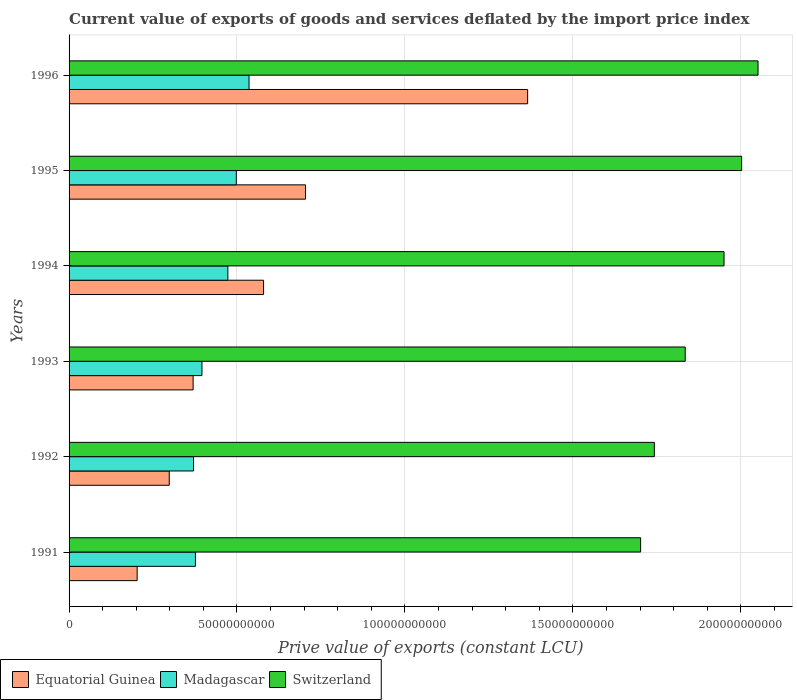Are the number of bars per tick equal to the number of legend labels?
Ensure brevity in your answer.  Yes. How many bars are there on the 4th tick from the top?
Ensure brevity in your answer.  3. In how many cases, is the number of bars for a given year not equal to the number of legend labels?
Offer a very short reply. 0. What is the prive value of exports in Switzerland in 1992?
Provide a succinct answer. 1.74e+11. Across all years, what is the maximum prive value of exports in Equatorial Guinea?
Provide a succinct answer. 1.37e+11. Across all years, what is the minimum prive value of exports in Switzerland?
Ensure brevity in your answer.  1.70e+11. In which year was the prive value of exports in Madagascar minimum?
Make the answer very short. 1992. What is the total prive value of exports in Madagascar in the graph?
Offer a very short reply. 2.65e+11. What is the difference between the prive value of exports in Switzerland in 1993 and that in 1995?
Ensure brevity in your answer.  -1.68e+1. What is the difference between the prive value of exports in Switzerland in 1993 and the prive value of exports in Madagascar in 1991?
Provide a short and direct response. 1.46e+11. What is the average prive value of exports in Equatorial Guinea per year?
Offer a terse response. 5.86e+1. In the year 1994, what is the difference between the prive value of exports in Equatorial Guinea and prive value of exports in Madagascar?
Provide a short and direct response. 1.06e+1. What is the ratio of the prive value of exports in Switzerland in 1993 to that in 1994?
Ensure brevity in your answer.  0.94. Is the prive value of exports in Madagascar in 1992 less than that in 1996?
Keep it short and to the point. Yes. Is the difference between the prive value of exports in Equatorial Guinea in 1993 and 1995 greater than the difference between the prive value of exports in Madagascar in 1993 and 1995?
Your answer should be very brief. No. What is the difference between the highest and the second highest prive value of exports in Switzerland?
Give a very brief answer. 4.89e+09. What is the difference between the highest and the lowest prive value of exports in Equatorial Guinea?
Provide a succinct answer. 1.16e+11. Is the sum of the prive value of exports in Madagascar in 1992 and 1994 greater than the maximum prive value of exports in Equatorial Guinea across all years?
Provide a short and direct response. No. What does the 3rd bar from the top in 1996 represents?
Provide a succinct answer. Equatorial Guinea. What does the 1st bar from the bottom in 1992 represents?
Your answer should be compact. Equatorial Guinea. How many bars are there?
Keep it short and to the point. 18. How many years are there in the graph?
Give a very brief answer. 6. What is the difference between two consecutive major ticks on the X-axis?
Your answer should be compact. 5.00e+1. Does the graph contain any zero values?
Keep it short and to the point. No. Does the graph contain grids?
Your answer should be very brief. Yes. Where does the legend appear in the graph?
Your answer should be compact. Bottom left. How many legend labels are there?
Ensure brevity in your answer.  3. What is the title of the graph?
Provide a short and direct response. Current value of exports of goods and services deflated by the import price index. What is the label or title of the X-axis?
Offer a very short reply. Prive value of exports (constant LCU). What is the Prive value of exports (constant LCU) of Equatorial Guinea in 1991?
Offer a terse response. 2.03e+1. What is the Prive value of exports (constant LCU) in Madagascar in 1991?
Make the answer very short. 3.76e+1. What is the Prive value of exports (constant LCU) in Switzerland in 1991?
Make the answer very short. 1.70e+11. What is the Prive value of exports (constant LCU) of Equatorial Guinea in 1992?
Give a very brief answer. 2.98e+1. What is the Prive value of exports (constant LCU) of Madagascar in 1992?
Your answer should be very brief. 3.71e+1. What is the Prive value of exports (constant LCU) in Switzerland in 1992?
Your response must be concise. 1.74e+11. What is the Prive value of exports (constant LCU) of Equatorial Guinea in 1993?
Offer a terse response. 3.69e+1. What is the Prive value of exports (constant LCU) in Madagascar in 1993?
Ensure brevity in your answer.  3.96e+1. What is the Prive value of exports (constant LCU) of Switzerland in 1993?
Provide a short and direct response. 1.83e+11. What is the Prive value of exports (constant LCU) of Equatorial Guinea in 1994?
Keep it short and to the point. 5.79e+1. What is the Prive value of exports (constant LCU) in Madagascar in 1994?
Ensure brevity in your answer.  4.73e+1. What is the Prive value of exports (constant LCU) of Switzerland in 1994?
Your answer should be very brief. 1.95e+11. What is the Prive value of exports (constant LCU) of Equatorial Guinea in 1995?
Keep it short and to the point. 7.04e+1. What is the Prive value of exports (constant LCU) of Madagascar in 1995?
Give a very brief answer. 4.98e+1. What is the Prive value of exports (constant LCU) in Switzerland in 1995?
Provide a short and direct response. 2.00e+11. What is the Prive value of exports (constant LCU) in Equatorial Guinea in 1996?
Provide a short and direct response. 1.37e+11. What is the Prive value of exports (constant LCU) of Madagascar in 1996?
Provide a short and direct response. 5.36e+1. What is the Prive value of exports (constant LCU) in Switzerland in 1996?
Ensure brevity in your answer.  2.05e+11. Across all years, what is the maximum Prive value of exports (constant LCU) in Equatorial Guinea?
Your answer should be very brief. 1.37e+11. Across all years, what is the maximum Prive value of exports (constant LCU) in Madagascar?
Provide a succinct answer. 5.36e+1. Across all years, what is the maximum Prive value of exports (constant LCU) in Switzerland?
Your answer should be compact. 2.05e+11. Across all years, what is the minimum Prive value of exports (constant LCU) in Equatorial Guinea?
Your answer should be compact. 2.03e+1. Across all years, what is the minimum Prive value of exports (constant LCU) in Madagascar?
Your answer should be very brief. 3.71e+1. Across all years, what is the minimum Prive value of exports (constant LCU) in Switzerland?
Offer a very short reply. 1.70e+11. What is the total Prive value of exports (constant LCU) in Equatorial Guinea in the graph?
Provide a short and direct response. 3.52e+11. What is the total Prive value of exports (constant LCU) of Madagascar in the graph?
Your answer should be compact. 2.65e+11. What is the total Prive value of exports (constant LCU) of Switzerland in the graph?
Keep it short and to the point. 1.13e+12. What is the difference between the Prive value of exports (constant LCU) in Equatorial Guinea in 1991 and that in 1992?
Your answer should be very brief. -9.55e+09. What is the difference between the Prive value of exports (constant LCU) of Madagascar in 1991 and that in 1992?
Ensure brevity in your answer.  5.64e+08. What is the difference between the Prive value of exports (constant LCU) of Switzerland in 1991 and that in 1992?
Make the answer very short. -4.08e+09. What is the difference between the Prive value of exports (constant LCU) in Equatorial Guinea in 1991 and that in 1993?
Your answer should be very brief. -1.67e+1. What is the difference between the Prive value of exports (constant LCU) of Madagascar in 1991 and that in 1993?
Provide a short and direct response. -1.94e+09. What is the difference between the Prive value of exports (constant LCU) in Switzerland in 1991 and that in 1993?
Provide a short and direct response. -1.33e+1. What is the difference between the Prive value of exports (constant LCU) in Equatorial Guinea in 1991 and that in 1994?
Your response must be concise. -3.76e+1. What is the difference between the Prive value of exports (constant LCU) of Madagascar in 1991 and that in 1994?
Offer a terse response. -9.65e+09. What is the difference between the Prive value of exports (constant LCU) in Switzerland in 1991 and that in 1994?
Give a very brief answer. -2.48e+1. What is the difference between the Prive value of exports (constant LCU) of Equatorial Guinea in 1991 and that in 1995?
Give a very brief answer. -5.01e+1. What is the difference between the Prive value of exports (constant LCU) of Madagascar in 1991 and that in 1995?
Provide a succinct answer. -1.22e+1. What is the difference between the Prive value of exports (constant LCU) in Switzerland in 1991 and that in 1995?
Offer a very short reply. -3.01e+1. What is the difference between the Prive value of exports (constant LCU) of Equatorial Guinea in 1991 and that in 1996?
Your response must be concise. -1.16e+11. What is the difference between the Prive value of exports (constant LCU) in Madagascar in 1991 and that in 1996?
Make the answer very short. -1.60e+1. What is the difference between the Prive value of exports (constant LCU) of Switzerland in 1991 and that in 1996?
Your answer should be very brief. -3.50e+1. What is the difference between the Prive value of exports (constant LCU) in Equatorial Guinea in 1992 and that in 1993?
Provide a short and direct response. -7.11e+09. What is the difference between the Prive value of exports (constant LCU) in Madagascar in 1992 and that in 1993?
Offer a terse response. -2.50e+09. What is the difference between the Prive value of exports (constant LCU) of Switzerland in 1992 and that in 1993?
Give a very brief answer. -9.20e+09. What is the difference between the Prive value of exports (constant LCU) in Equatorial Guinea in 1992 and that in 1994?
Your response must be concise. -2.81e+1. What is the difference between the Prive value of exports (constant LCU) in Madagascar in 1992 and that in 1994?
Offer a terse response. -1.02e+1. What is the difference between the Prive value of exports (constant LCU) of Switzerland in 1992 and that in 1994?
Provide a succinct answer. -2.08e+1. What is the difference between the Prive value of exports (constant LCU) in Equatorial Guinea in 1992 and that in 1995?
Your answer should be very brief. -4.06e+1. What is the difference between the Prive value of exports (constant LCU) in Madagascar in 1992 and that in 1995?
Keep it short and to the point. -1.27e+1. What is the difference between the Prive value of exports (constant LCU) in Switzerland in 1992 and that in 1995?
Ensure brevity in your answer.  -2.60e+1. What is the difference between the Prive value of exports (constant LCU) of Equatorial Guinea in 1992 and that in 1996?
Your answer should be very brief. -1.07e+11. What is the difference between the Prive value of exports (constant LCU) of Madagascar in 1992 and that in 1996?
Your answer should be compact. -1.65e+1. What is the difference between the Prive value of exports (constant LCU) of Switzerland in 1992 and that in 1996?
Ensure brevity in your answer.  -3.09e+1. What is the difference between the Prive value of exports (constant LCU) of Equatorial Guinea in 1993 and that in 1994?
Ensure brevity in your answer.  -2.10e+1. What is the difference between the Prive value of exports (constant LCU) in Madagascar in 1993 and that in 1994?
Give a very brief answer. -7.71e+09. What is the difference between the Prive value of exports (constant LCU) of Switzerland in 1993 and that in 1994?
Ensure brevity in your answer.  -1.16e+1. What is the difference between the Prive value of exports (constant LCU) of Equatorial Guinea in 1993 and that in 1995?
Your response must be concise. -3.35e+1. What is the difference between the Prive value of exports (constant LCU) in Madagascar in 1993 and that in 1995?
Your response must be concise. -1.02e+1. What is the difference between the Prive value of exports (constant LCU) of Switzerland in 1993 and that in 1995?
Your answer should be very brief. -1.68e+1. What is the difference between the Prive value of exports (constant LCU) of Equatorial Guinea in 1993 and that in 1996?
Offer a very short reply. -9.96e+1. What is the difference between the Prive value of exports (constant LCU) of Madagascar in 1993 and that in 1996?
Provide a short and direct response. -1.40e+1. What is the difference between the Prive value of exports (constant LCU) in Switzerland in 1993 and that in 1996?
Your response must be concise. -2.17e+1. What is the difference between the Prive value of exports (constant LCU) of Equatorial Guinea in 1994 and that in 1995?
Your answer should be very brief. -1.25e+1. What is the difference between the Prive value of exports (constant LCU) of Madagascar in 1994 and that in 1995?
Offer a very short reply. -2.52e+09. What is the difference between the Prive value of exports (constant LCU) of Switzerland in 1994 and that in 1995?
Keep it short and to the point. -5.24e+09. What is the difference between the Prive value of exports (constant LCU) of Equatorial Guinea in 1994 and that in 1996?
Your answer should be very brief. -7.86e+1. What is the difference between the Prive value of exports (constant LCU) of Madagascar in 1994 and that in 1996?
Make the answer very short. -6.30e+09. What is the difference between the Prive value of exports (constant LCU) in Switzerland in 1994 and that in 1996?
Make the answer very short. -1.01e+1. What is the difference between the Prive value of exports (constant LCU) in Equatorial Guinea in 1995 and that in 1996?
Make the answer very short. -6.62e+1. What is the difference between the Prive value of exports (constant LCU) in Madagascar in 1995 and that in 1996?
Keep it short and to the point. -3.79e+09. What is the difference between the Prive value of exports (constant LCU) of Switzerland in 1995 and that in 1996?
Your response must be concise. -4.89e+09. What is the difference between the Prive value of exports (constant LCU) in Equatorial Guinea in 1991 and the Prive value of exports (constant LCU) in Madagascar in 1992?
Give a very brief answer. -1.68e+1. What is the difference between the Prive value of exports (constant LCU) in Equatorial Guinea in 1991 and the Prive value of exports (constant LCU) in Switzerland in 1992?
Provide a succinct answer. -1.54e+11. What is the difference between the Prive value of exports (constant LCU) of Madagascar in 1991 and the Prive value of exports (constant LCU) of Switzerland in 1992?
Your response must be concise. -1.37e+11. What is the difference between the Prive value of exports (constant LCU) in Equatorial Guinea in 1991 and the Prive value of exports (constant LCU) in Madagascar in 1993?
Offer a very short reply. -1.93e+1. What is the difference between the Prive value of exports (constant LCU) in Equatorial Guinea in 1991 and the Prive value of exports (constant LCU) in Switzerland in 1993?
Your answer should be very brief. -1.63e+11. What is the difference between the Prive value of exports (constant LCU) of Madagascar in 1991 and the Prive value of exports (constant LCU) of Switzerland in 1993?
Provide a succinct answer. -1.46e+11. What is the difference between the Prive value of exports (constant LCU) in Equatorial Guinea in 1991 and the Prive value of exports (constant LCU) in Madagascar in 1994?
Give a very brief answer. -2.70e+1. What is the difference between the Prive value of exports (constant LCU) of Equatorial Guinea in 1991 and the Prive value of exports (constant LCU) of Switzerland in 1994?
Your answer should be very brief. -1.75e+11. What is the difference between the Prive value of exports (constant LCU) in Madagascar in 1991 and the Prive value of exports (constant LCU) in Switzerland in 1994?
Your answer should be very brief. -1.57e+11. What is the difference between the Prive value of exports (constant LCU) in Equatorial Guinea in 1991 and the Prive value of exports (constant LCU) in Madagascar in 1995?
Give a very brief answer. -2.95e+1. What is the difference between the Prive value of exports (constant LCU) in Equatorial Guinea in 1991 and the Prive value of exports (constant LCU) in Switzerland in 1995?
Ensure brevity in your answer.  -1.80e+11. What is the difference between the Prive value of exports (constant LCU) in Madagascar in 1991 and the Prive value of exports (constant LCU) in Switzerland in 1995?
Provide a short and direct response. -1.63e+11. What is the difference between the Prive value of exports (constant LCU) of Equatorial Guinea in 1991 and the Prive value of exports (constant LCU) of Madagascar in 1996?
Offer a terse response. -3.33e+1. What is the difference between the Prive value of exports (constant LCU) of Equatorial Guinea in 1991 and the Prive value of exports (constant LCU) of Switzerland in 1996?
Offer a very short reply. -1.85e+11. What is the difference between the Prive value of exports (constant LCU) in Madagascar in 1991 and the Prive value of exports (constant LCU) in Switzerland in 1996?
Ensure brevity in your answer.  -1.68e+11. What is the difference between the Prive value of exports (constant LCU) of Equatorial Guinea in 1992 and the Prive value of exports (constant LCU) of Madagascar in 1993?
Give a very brief answer. -9.74e+09. What is the difference between the Prive value of exports (constant LCU) in Equatorial Guinea in 1992 and the Prive value of exports (constant LCU) in Switzerland in 1993?
Your response must be concise. -1.54e+11. What is the difference between the Prive value of exports (constant LCU) in Madagascar in 1992 and the Prive value of exports (constant LCU) in Switzerland in 1993?
Provide a succinct answer. -1.46e+11. What is the difference between the Prive value of exports (constant LCU) of Equatorial Guinea in 1992 and the Prive value of exports (constant LCU) of Madagascar in 1994?
Make the answer very short. -1.75e+1. What is the difference between the Prive value of exports (constant LCU) of Equatorial Guinea in 1992 and the Prive value of exports (constant LCU) of Switzerland in 1994?
Your answer should be compact. -1.65e+11. What is the difference between the Prive value of exports (constant LCU) in Madagascar in 1992 and the Prive value of exports (constant LCU) in Switzerland in 1994?
Ensure brevity in your answer.  -1.58e+11. What is the difference between the Prive value of exports (constant LCU) of Equatorial Guinea in 1992 and the Prive value of exports (constant LCU) of Madagascar in 1995?
Ensure brevity in your answer.  -2.00e+1. What is the difference between the Prive value of exports (constant LCU) of Equatorial Guinea in 1992 and the Prive value of exports (constant LCU) of Switzerland in 1995?
Your response must be concise. -1.70e+11. What is the difference between the Prive value of exports (constant LCU) of Madagascar in 1992 and the Prive value of exports (constant LCU) of Switzerland in 1995?
Offer a terse response. -1.63e+11. What is the difference between the Prive value of exports (constant LCU) of Equatorial Guinea in 1992 and the Prive value of exports (constant LCU) of Madagascar in 1996?
Your response must be concise. -2.38e+1. What is the difference between the Prive value of exports (constant LCU) in Equatorial Guinea in 1992 and the Prive value of exports (constant LCU) in Switzerland in 1996?
Your answer should be very brief. -1.75e+11. What is the difference between the Prive value of exports (constant LCU) of Madagascar in 1992 and the Prive value of exports (constant LCU) of Switzerland in 1996?
Give a very brief answer. -1.68e+11. What is the difference between the Prive value of exports (constant LCU) in Equatorial Guinea in 1993 and the Prive value of exports (constant LCU) in Madagascar in 1994?
Provide a short and direct response. -1.03e+1. What is the difference between the Prive value of exports (constant LCU) of Equatorial Guinea in 1993 and the Prive value of exports (constant LCU) of Switzerland in 1994?
Offer a very short reply. -1.58e+11. What is the difference between the Prive value of exports (constant LCU) in Madagascar in 1993 and the Prive value of exports (constant LCU) in Switzerland in 1994?
Make the answer very short. -1.55e+11. What is the difference between the Prive value of exports (constant LCU) of Equatorial Guinea in 1993 and the Prive value of exports (constant LCU) of Madagascar in 1995?
Your response must be concise. -1.29e+1. What is the difference between the Prive value of exports (constant LCU) of Equatorial Guinea in 1993 and the Prive value of exports (constant LCU) of Switzerland in 1995?
Your answer should be compact. -1.63e+11. What is the difference between the Prive value of exports (constant LCU) in Madagascar in 1993 and the Prive value of exports (constant LCU) in Switzerland in 1995?
Offer a very short reply. -1.61e+11. What is the difference between the Prive value of exports (constant LCU) of Equatorial Guinea in 1993 and the Prive value of exports (constant LCU) of Madagascar in 1996?
Keep it short and to the point. -1.66e+1. What is the difference between the Prive value of exports (constant LCU) of Equatorial Guinea in 1993 and the Prive value of exports (constant LCU) of Switzerland in 1996?
Your answer should be very brief. -1.68e+11. What is the difference between the Prive value of exports (constant LCU) of Madagascar in 1993 and the Prive value of exports (constant LCU) of Switzerland in 1996?
Ensure brevity in your answer.  -1.66e+11. What is the difference between the Prive value of exports (constant LCU) of Equatorial Guinea in 1994 and the Prive value of exports (constant LCU) of Madagascar in 1995?
Keep it short and to the point. 8.11e+09. What is the difference between the Prive value of exports (constant LCU) of Equatorial Guinea in 1994 and the Prive value of exports (constant LCU) of Switzerland in 1995?
Provide a succinct answer. -1.42e+11. What is the difference between the Prive value of exports (constant LCU) of Madagascar in 1994 and the Prive value of exports (constant LCU) of Switzerland in 1995?
Keep it short and to the point. -1.53e+11. What is the difference between the Prive value of exports (constant LCU) of Equatorial Guinea in 1994 and the Prive value of exports (constant LCU) of Madagascar in 1996?
Your answer should be very brief. 4.33e+09. What is the difference between the Prive value of exports (constant LCU) in Equatorial Guinea in 1994 and the Prive value of exports (constant LCU) in Switzerland in 1996?
Give a very brief answer. -1.47e+11. What is the difference between the Prive value of exports (constant LCU) of Madagascar in 1994 and the Prive value of exports (constant LCU) of Switzerland in 1996?
Provide a succinct answer. -1.58e+11. What is the difference between the Prive value of exports (constant LCU) of Equatorial Guinea in 1995 and the Prive value of exports (constant LCU) of Madagascar in 1996?
Ensure brevity in your answer.  1.68e+1. What is the difference between the Prive value of exports (constant LCU) in Equatorial Guinea in 1995 and the Prive value of exports (constant LCU) in Switzerland in 1996?
Your answer should be very brief. -1.35e+11. What is the difference between the Prive value of exports (constant LCU) of Madagascar in 1995 and the Prive value of exports (constant LCU) of Switzerland in 1996?
Keep it short and to the point. -1.55e+11. What is the average Prive value of exports (constant LCU) in Equatorial Guinea per year?
Provide a short and direct response. 5.86e+1. What is the average Prive value of exports (constant LCU) in Madagascar per year?
Provide a succinct answer. 4.42e+1. What is the average Prive value of exports (constant LCU) of Switzerland per year?
Keep it short and to the point. 1.88e+11. In the year 1991, what is the difference between the Prive value of exports (constant LCU) in Equatorial Guinea and Prive value of exports (constant LCU) in Madagascar?
Keep it short and to the point. -1.74e+1. In the year 1991, what is the difference between the Prive value of exports (constant LCU) of Equatorial Guinea and Prive value of exports (constant LCU) of Switzerland?
Provide a short and direct response. -1.50e+11. In the year 1991, what is the difference between the Prive value of exports (constant LCU) of Madagascar and Prive value of exports (constant LCU) of Switzerland?
Your response must be concise. -1.33e+11. In the year 1992, what is the difference between the Prive value of exports (constant LCU) in Equatorial Guinea and Prive value of exports (constant LCU) in Madagascar?
Provide a short and direct response. -7.23e+09. In the year 1992, what is the difference between the Prive value of exports (constant LCU) of Equatorial Guinea and Prive value of exports (constant LCU) of Switzerland?
Give a very brief answer. -1.44e+11. In the year 1992, what is the difference between the Prive value of exports (constant LCU) in Madagascar and Prive value of exports (constant LCU) in Switzerland?
Ensure brevity in your answer.  -1.37e+11. In the year 1993, what is the difference between the Prive value of exports (constant LCU) of Equatorial Guinea and Prive value of exports (constant LCU) of Madagascar?
Provide a succinct answer. -2.63e+09. In the year 1993, what is the difference between the Prive value of exports (constant LCU) of Equatorial Guinea and Prive value of exports (constant LCU) of Switzerland?
Your answer should be very brief. -1.47e+11. In the year 1993, what is the difference between the Prive value of exports (constant LCU) in Madagascar and Prive value of exports (constant LCU) in Switzerland?
Your answer should be very brief. -1.44e+11. In the year 1994, what is the difference between the Prive value of exports (constant LCU) of Equatorial Guinea and Prive value of exports (constant LCU) of Madagascar?
Keep it short and to the point. 1.06e+1. In the year 1994, what is the difference between the Prive value of exports (constant LCU) of Equatorial Guinea and Prive value of exports (constant LCU) of Switzerland?
Offer a terse response. -1.37e+11. In the year 1994, what is the difference between the Prive value of exports (constant LCU) of Madagascar and Prive value of exports (constant LCU) of Switzerland?
Provide a short and direct response. -1.48e+11. In the year 1995, what is the difference between the Prive value of exports (constant LCU) of Equatorial Guinea and Prive value of exports (constant LCU) of Madagascar?
Keep it short and to the point. 2.06e+1. In the year 1995, what is the difference between the Prive value of exports (constant LCU) of Equatorial Guinea and Prive value of exports (constant LCU) of Switzerland?
Your response must be concise. -1.30e+11. In the year 1995, what is the difference between the Prive value of exports (constant LCU) of Madagascar and Prive value of exports (constant LCU) of Switzerland?
Make the answer very short. -1.50e+11. In the year 1996, what is the difference between the Prive value of exports (constant LCU) of Equatorial Guinea and Prive value of exports (constant LCU) of Madagascar?
Offer a terse response. 8.30e+1. In the year 1996, what is the difference between the Prive value of exports (constant LCU) in Equatorial Guinea and Prive value of exports (constant LCU) in Switzerland?
Your response must be concise. -6.86e+1. In the year 1996, what is the difference between the Prive value of exports (constant LCU) in Madagascar and Prive value of exports (constant LCU) in Switzerland?
Your response must be concise. -1.52e+11. What is the ratio of the Prive value of exports (constant LCU) in Equatorial Guinea in 1991 to that in 1992?
Keep it short and to the point. 0.68. What is the ratio of the Prive value of exports (constant LCU) in Madagascar in 1991 to that in 1992?
Provide a short and direct response. 1.02. What is the ratio of the Prive value of exports (constant LCU) of Switzerland in 1991 to that in 1992?
Your answer should be compact. 0.98. What is the ratio of the Prive value of exports (constant LCU) of Equatorial Guinea in 1991 to that in 1993?
Offer a terse response. 0.55. What is the ratio of the Prive value of exports (constant LCU) of Madagascar in 1991 to that in 1993?
Offer a very short reply. 0.95. What is the ratio of the Prive value of exports (constant LCU) in Switzerland in 1991 to that in 1993?
Make the answer very short. 0.93. What is the ratio of the Prive value of exports (constant LCU) of Equatorial Guinea in 1991 to that in 1994?
Give a very brief answer. 0.35. What is the ratio of the Prive value of exports (constant LCU) in Madagascar in 1991 to that in 1994?
Your response must be concise. 0.8. What is the ratio of the Prive value of exports (constant LCU) in Switzerland in 1991 to that in 1994?
Make the answer very short. 0.87. What is the ratio of the Prive value of exports (constant LCU) of Equatorial Guinea in 1991 to that in 1995?
Make the answer very short. 0.29. What is the ratio of the Prive value of exports (constant LCU) in Madagascar in 1991 to that in 1995?
Your answer should be very brief. 0.76. What is the ratio of the Prive value of exports (constant LCU) in Switzerland in 1991 to that in 1995?
Provide a short and direct response. 0.85. What is the ratio of the Prive value of exports (constant LCU) of Equatorial Guinea in 1991 to that in 1996?
Offer a terse response. 0.15. What is the ratio of the Prive value of exports (constant LCU) of Madagascar in 1991 to that in 1996?
Make the answer very short. 0.7. What is the ratio of the Prive value of exports (constant LCU) of Switzerland in 1991 to that in 1996?
Provide a succinct answer. 0.83. What is the ratio of the Prive value of exports (constant LCU) in Equatorial Guinea in 1992 to that in 1993?
Your response must be concise. 0.81. What is the ratio of the Prive value of exports (constant LCU) in Madagascar in 1992 to that in 1993?
Your answer should be compact. 0.94. What is the ratio of the Prive value of exports (constant LCU) in Switzerland in 1992 to that in 1993?
Provide a short and direct response. 0.95. What is the ratio of the Prive value of exports (constant LCU) of Equatorial Guinea in 1992 to that in 1994?
Offer a very short reply. 0.52. What is the ratio of the Prive value of exports (constant LCU) in Madagascar in 1992 to that in 1994?
Your answer should be compact. 0.78. What is the ratio of the Prive value of exports (constant LCU) in Switzerland in 1992 to that in 1994?
Provide a short and direct response. 0.89. What is the ratio of the Prive value of exports (constant LCU) in Equatorial Guinea in 1992 to that in 1995?
Provide a succinct answer. 0.42. What is the ratio of the Prive value of exports (constant LCU) of Madagascar in 1992 to that in 1995?
Keep it short and to the point. 0.74. What is the ratio of the Prive value of exports (constant LCU) of Switzerland in 1992 to that in 1995?
Offer a very short reply. 0.87. What is the ratio of the Prive value of exports (constant LCU) in Equatorial Guinea in 1992 to that in 1996?
Offer a very short reply. 0.22. What is the ratio of the Prive value of exports (constant LCU) of Madagascar in 1992 to that in 1996?
Your answer should be very brief. 0.69. What is the ratio of the Prive value of exports (constant LCU) of Switzerland in 1992 to that in 1996?
Offer a very short reply. 0.85. What is the ratio of the Prive value of exports (constant LCU) of Equatorial Guinea in 1993 to that in 1994?
Keep it short and to the point. 0.64. What is the ratio of the Prive value of exports (constant LCU) of Madagascar in 1993 to that in 1994?
Offer a very short reply. 0.84. What is the ratio of the Prive value of exports (constant LCU) of Switzerland in 1993 to that in 1994?
Provide a short and direct response. 0.94. What is the ratio of the Prive value of exports (constant LCU) of Equatorial Guinea in 1993 to that in 1995?
Your answer should be very brief. 0.52. What is the ratio of the Prive value of exports (constant LCU) in Madagascar in 1993 to that in 1995?
Give a very brief answer. 0.79. What is the ratio of the Prive value of exports (constant LCU) in Switzerland in 1993 to that in 1995?
Offer a very short reply. 0.92. What is the ratio of the Prive value of exports (constant LCU) in Equatorial Guinea in 1993 to that in 1996?
Offer a terse response. 0.27. What is the ratio of the Prive value of exports (constant LCU) in Madagascar in 1993 to that in 1996?
Offer a very short reply. 0.74. What is the ratio of the Prive value of exports (constant LCU) of Switzerland in 1993 to that in 1996?
Keep it short and to the point. 0.89. What is the ratio of the Prive value of exports (constant LCU) of Equatorial Guinea in 1994 to that in 1995?
Make the answer very short. 0.82. What is the ratio of the Prive value of exports (constant LCU) of Madagascar in 1994 to that in 1995?
Your response must be concise. 0.95. What is the ratio of the Prive value of exports (constant LCU) in Switzerland in 1994 to that in 1995?
Ensure brevity in your answer.  0.97. What is the ratio of the Prive value of exports (constant LCU) of Equatorial Guinea in 1994 to that in 1996?
Your response must be concise. 0.42. What is the ratio of the Prive value of exports (constant LCU) of Madagascar in 1994 to that in 1996?
Make the answer very short. 0.88. What is the ratio of the Prive value of exports (constant LCU) in Switzerland in 1994 to that in 1996?
Your answer should be compact. 0.95. What is the ratio of the Prive value of exports (constant LCU) in Equatorial Guinea in 1995 to that in 1996?
Offer a very short reply. 0.52. What is the ratio of the Prive value of exports (constant LCU) in Madagascar in 1995 to that in 1996?
Your answer should be very brief. 0.93. What is the ratio of the Prive value of exports (constant LCU) in Switzerland in 1995 to that in 1996?
Offer a terse response. 0.98. What is the difference between the highest and the second highest Prive value of exports (constant LCU) of Equatorial Guinea?
Your response must be concise. 6.62e+1. What is the difference between the highest and the second highest Prive value of exports (constant LCU) of Madagascar?
Provide a succinct answer. 3.79e+09. What is the difference between the highest and the second highest Prive value of exports (constant LCU) of Switzerland?
Give a very brief answer. 4.89e+09. What is the difference between the highest and the lowest Prive value of exports (constant LCU) of Equatorial Guinea?
Give a very brief answer. 1.16e+11. What is the difference between the highest and the lowest Prive value of exports (constant LCU) in Madagascar?
Offer a terse response. 1.65e+1. What is the difference between the highest and the lowest Prive value of exports (constant LCU) in Switzerland?
Provide a succinct answer. 3.50e+1. 